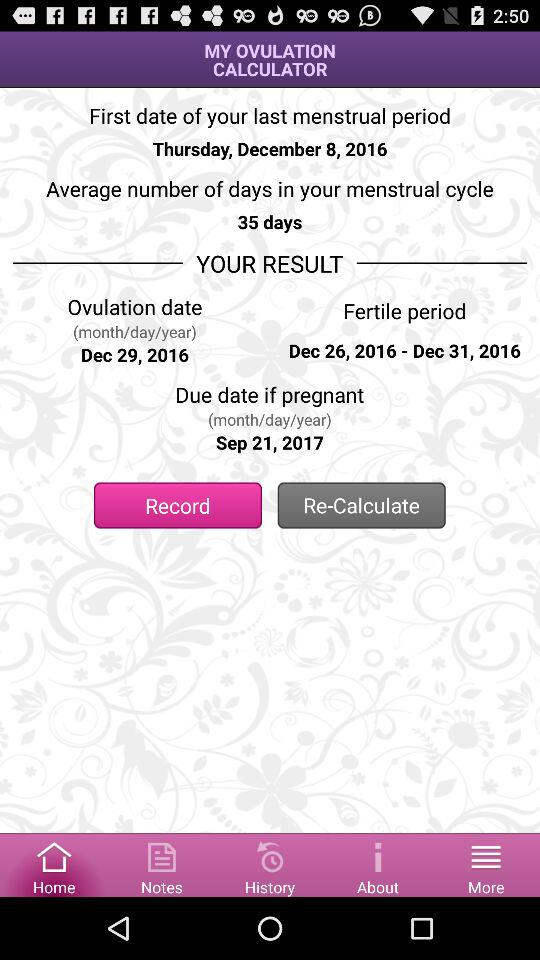September 21, 2017 is the date for what result? The result is "Due date if pregnant". 